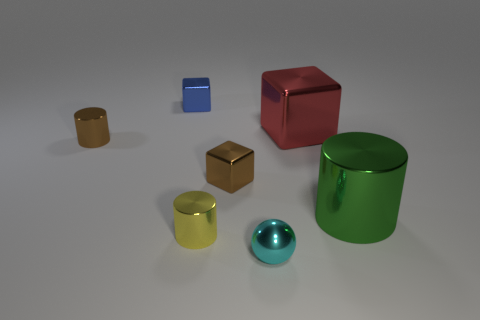Subtract all purple cylinders. Subtract all gray blocks. How many cylinders are left? 3 Add 1 small yellow cylinders. How many objects exist? 8 Subtract all blocks. How many objects are left? 4 Subtract 0 brown spheres. How many objects are left? 7 Subtract all big cylinders. Subtract all small shiny objects. How many objects are left? 1 Add 2 green metal cylinders. How many green metal cylinders are left? 3 Add 5 big gray cylinders. How many big gray cylinders exist? 5 